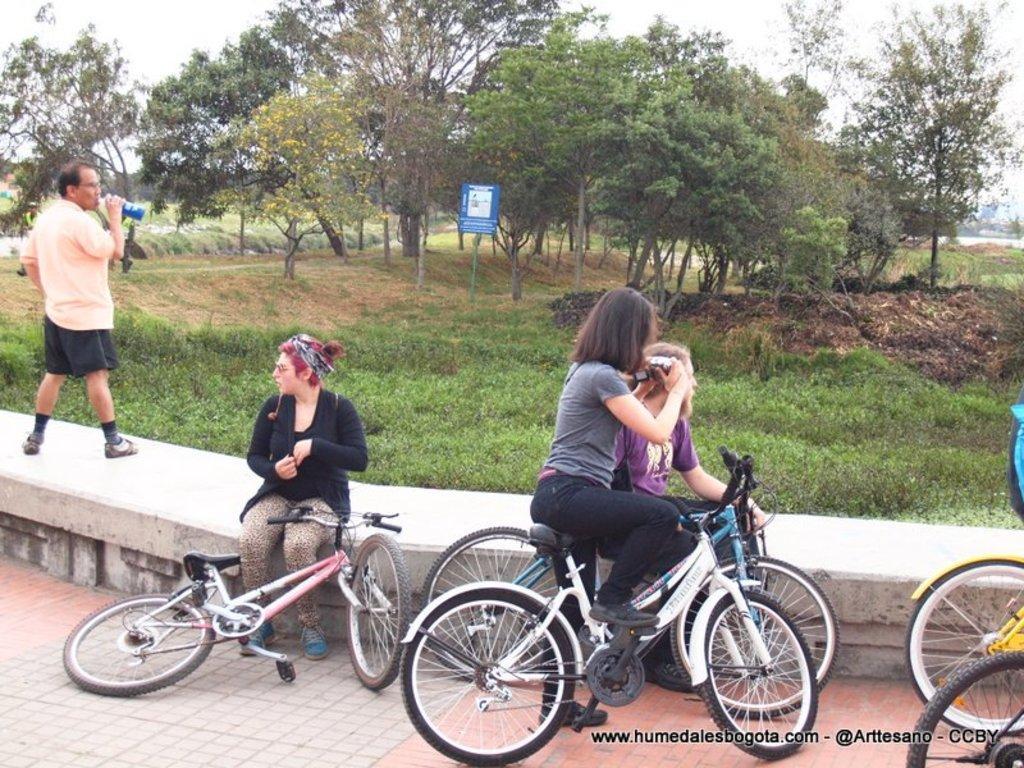Describe this image in one or two sentences. In this picture there are group of people those who are standing and taking rest at the side of foot path, area where they stood is greenery and some trees are there around there area of the image , the person who is standing at the left side of the image is drinking the water. 